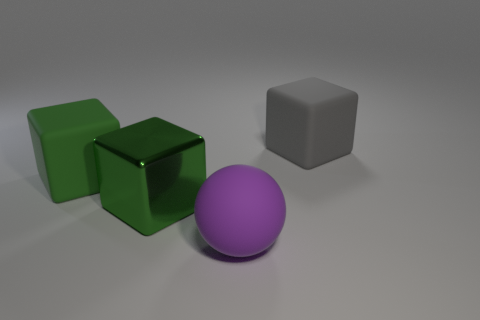Subtract all big green matte cubes. How many cubes are left? 2 Subtract all cubes. How many objects are left? 1 Subtract 1 blocks. How many blocks are left? 2 Add 3 big green cylinders. How many objects exist? 7 Subtract all gray blocks. How many blocks are left? 2 Subtract all brown balls. Subtract all blue blocks. How many balls are left? 1 Subtract all purple blocks. How many green spheres are left? 0 Subtract all big red rubber spheres. Subtract all matte cubes. How many objects are left? 2 Add 1 big green metal blocks. How many big green metal blocks are left? 2 Add 3 large gray things. How many large gray things exist? 4 